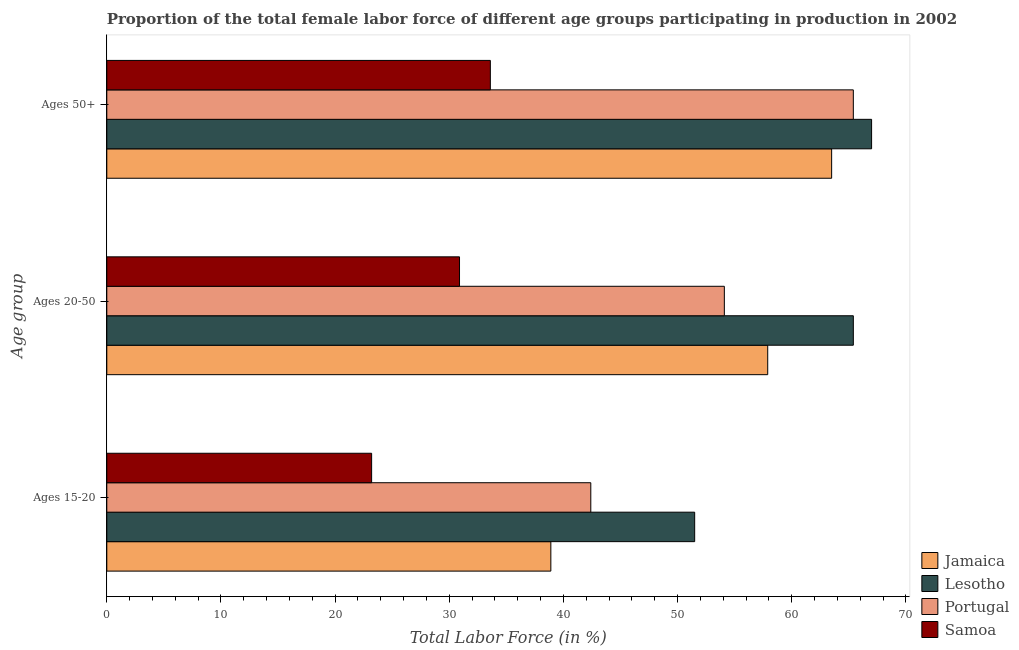Are the number of bars per tick equal to the number of legend labels?
Offer a very short reply. Yes. Are the number of bars on each tick of the Y-axis equal?
Your answer should be very brief. Yes. What is the label of the 3rd group of bars from the top?
Offer a terse response. Ages 15-20. What is the percentage of female labor force within the age group 15-20 in Samoa?
Keep it short and to the point. 23.2. Across all countries, what is the maximum percentage of female labor force within the age group 20-50?
Offer a terse response. 65.4. Across all countries, what is the minimum percentage of female labor force above age 50?
Ensure brevity in your answer.  33.6. In which country was the percentage of female labor force within the age group 20-50 maximum?
Provide a short and direct response. Lesotho. In which country was the percentage of female labor force within the age group 15-20 minimum?
Provide a succinct answer. Samoa. What is the total percentage of female labor force within the age group 20-50 in the graph?
Offer a terse response. 208.3. What is the difference between the percentage of female labor force within the age group 20-50 in Lesotho and that in Samoa?
Offer a terse response. 34.5. What is the difference between the percentage of female labor force above age 50 in Portugal and the percentage of female labor force within the age group 20-50 in Jamaica?
Offer a terse response. 7.5. What is the average percentage of female labor force within the age group 20-50 per country?
Provide a succinct answer. 52.08. What is the difference between the percentage of female labor force within the age group 15-20 and percentage of female labor force within the age group 20-50 in Samoa?
Ensure brevity in your answer.  -7.7. What is the ratio of the percentage of female labor force above age 50 in Jamaica to that in Lesotho?
Make the answer very short. 0.95. Is the percentage of female labor force above age 50 in Portugal less than that in Samoa?
Offer a terse response. No. Is the difference between the percentage of female labor force within the age group 15-20 in Portugal and Jamaica greater than the difference between the percentage of female labor force above age 50 in Portugal and Jamaica?
Provide a short and direct response. Yes. What is the difference between the highest and the second highest percentage of female labor force within the age group 20-50?
Offer a terse response. 7.5. What is the difference between the highest and the lowest percentage of female labor force within the age group 15-20?
Your answer should be very brief. 28.3. In how many countries, is the percentage of female labor force above age 50 greater than the average percentage of female labor force above age 50 taken over all countries?
Keep it short and to the point. 3. What does the 4th bar from the top in Ages 15-20 represents?
Provide a succinct answer. Jamaica. What does the 1st bar from the bottom in Ages 50+ represents?
Give a very brief answer. Jamaica. How many bars are there?
Offer a terse response. 12. Are all the bars in the graph horizontal?
Your answer should be very brief. Yes. How many countries are there in the graph?
Provide a short and direct response. 4. What is the difference between two consecutive major ticks on the X-axis?
Make the answer very short. 10. Are the values on the major ticks of X-axis written in scientific E-notation?
Offer a terse response. No. Does the graph contain any zero values?
Ensure brevity in your answer.  No. How are the legend labels stacked?
Ensure brevity in your answer.  Vertical. What is the title of the graph?
Make the answer very short. Proportion of the total female labor force of different age groups participating in production in 2002. What is the label or title of the Y-axis?
Your answer should be very brief. Age group. What is the Total Labor Force (in %) of Jamaica in Ages 15-20?
Ensure brevity in your answer.  38.9. What is the Total Labor Force (in %) of Lesotho in Ages 15-20?
Make the answer very short. 51.5. What is the Total Labor Force (in %) in Portugal in Ages 15-20?
Offer a very short reply. 42.4. What is the Total Labor Force (in %) in Samoa in Ages 15-20?
Your response must be concise. 23.2. What is the Total Labor Force (in %) in Jamaica in Ages 20-50?
Your answer should be very brief. 57.9. What is the Total Labor Force (in %) of Lesotho in Ages 20-50?
Give a very brief answer. 65.4. What is the Total Labor Force (in %) of Portugal in Ages 20-50?
Offer a terse response. 54.1. What is the Total Labor Force (in %) in Samoa in Ages 20-50?
Your answer should be compact. 30.9. What is the Total Labor Force (in %) of Jamaica in Ages 50+?
Give a very brief answer. 63.5. What is the Total Labor Force (in %) in Portugal in Ages 50+?
Provide a short and direct response. 65.4. What is the Total Labor Force (in %) of Samoa in Ages 50+?
Offer a very short reply. 33.6. Across all Age group, what is the maximum Total Labor Force (in %) of Jamaica?
Offer a terse response. 63.5. Across all Age group, what is the maximum Total Labor Force (in %) of Portugal?
Your answer should be very brief. 65.4. Across all Age group, what is the maximum Total Labor Force (in %) in Samoa?
Provide a succinct answer. 33.6. Across all Age group, what is the minimum Total Labor Force (in %) of Jamaica?
Give a very brief answer. 38.9. Across all Age group, what is the minimum Total Labor Force (in %) in Lesotho?
Provide a succinct answer. 51.5. Across all Age group, what is the minimum Total Labor Force (in %) of Portugal?
Ensure brevity in your answer.  42.4. Across all Age group, what is the minimum Total Labor Force (in %) in Samoa?
Give a very brief answer. 23.2. What is the total Total Labor Force (in %) in Jamaica in the graph?
Make the answer very short. 160.3. What is the total Total Labor Force (in %) of Lesotho in the graph?
Your response must be concise. 183.9. What is the total Total Labor Force (in %) in Portugal in the graph?
Ensure brevity in your answer.  161.9. What is the total Total Labor Force (in %) in Samoa in the graph?
Give a very brief answer. 87.7. What is the difference between the Total Labor Force (in %) of Lesotho in Ages 15-20 and that in Ages 20-50?
Provide a short and direct response. -13.9. What is the difference between the Total Labor Force (in %) of Portugal in Ages 15-20 and that in Ages 20-50?
Make the answer very short. -11.7. What is the difference between the Total Labor Force (in %) in Samoa in Ages 15-20 and that in Ages 20-50?
Provide a succinct answer. -7.7. What is the difference between the Total Labor Force (in %) of Jamaica in Ages 15-20 and that in Ages 50+?
Give a very brief answer. -24.6. What is the difference between the Total Labor Force (in %) in Lesotho in Ages 15-20 and that in Ages 50+?
Provide a succinct answer. -15.5. What is the difference between the Total Labor Force (in %) of Samoa in Ages 15-20 and that in Ages 50+?
Your response must be concise. -10.4. What is the difference between the Total Labor Force (in %) in Lesotho in Ages 20-50 and that in Ages 50+?
Offer a terse response. -1.6. What is the difference between the Total Labor Force (in %) in Portugal in Ages 20-50 and that in Ages 50+?
Provide a short and direct response. -11.3. What is the difference between the Total Labor Force (in %) of Samoa in Ages 20-50 and that in Ages 50+?
Provide a short and direct response. -2.7. What is the difference between the Total Labor Force (in %) in Jamaica in Ages 15-20 and the Total Labor Force (in %) in Lesotho in Ages 20-50?
Provide a succinct answer. -26.5. What is the difference between the Total Labor Force (in %) in Jamaica in Ages 15-20 and the Total Labor Force (in %) in Portugal in Ages 20-50?
Offer a terse response. -15.2. What is the difference between the Total Labor Force (in %) of Jamaica in Ages 15-20 and the Total Labor Force (in %) of Samoa in Ages 20-50?
Your response must be concise. 8. What is the difference between the Total Labor Force (in %) of Lesotho in Ages 15-20 and the Total Labor Force (in %) of Samoa in Ages 20-50?
Offer a very short reply. 20.6. What is the difference between the Total Labor Force (in %) of Jamaica in Ages 15-20 and the Total Labor Force (in %) of Lesotho in Ages 50+?
Make the answer very short. -28.1. What is the difference between the Total Labor Force (in %) of Jamaica in Ages 15-20 and the Total Labor Force (in %) of Portugal in Ages 50+?
Provide a succinct answer. -26.5. What is the difference between the Total Labor Force (in %) of Lesotho in Ages 15-20 and the Total Labor Force (in %) of Portugal in Ages 50+?
Your response must be concise. -13.9. What is the difference between the Total Labor Force (in %) in Lesotho in Ages 15-20 and the Total Labor Force (in %) in Samoa in Ages 50+?
Offer a very short reply. 17.9. What is the difference between the Total Labor Force (in %) of Portugal in Ages 15-20 and the Total Labor Force (in %) of Samoa in Ages 50+?
Your answer should be compact. 8.8. What is the difference between the Total Labor Force (in %) of Jamaica in Ages 20-50 and the Total Labor Force (in %) of Lesotho in Ages 50+?
Give a very brief answer. -9.1. What is the difference between the Total Labor Force (in %) of Jamaica in Ages 20-50 and the Total Labor Force (in %) of Portugal in Ages 50+?
Offer a very short reply. -7.5. What is the difference between the Total Labor Force (in %) in Jamaica in Ages 20-50 and the Total Labor Force (in %) in Samoa in Ages 50+?
Your response must be concise. 24.3. What is the difference between the Total Labor Force (in %) of Lesotho in Ages 20-50 and the Total Labor Force (in %) of Samoa in Ages 50+?
Make the answer very short. 31.8. What is the difference between the Total Labor Force (in %) in Portugal in Ages 20-50 and the Total Labor Force (in %) in Samoa in Ages 50+?
Your answer should be very brief. 20.5. What is the average Total Labor Force (in %) of Jamaica per Age group?
Give a very brief answer. 53.43. What is the average Total Labor Force (in %) of Lesotho per Age group?
Provide a short and direct response. 61.3. What is the average Total Labor Force (in %) in Portugal per Age group?
Offer a very short reply. 53.97. What is the average Total Labor Force (in %) of Samoa per Age group?
Offer a very short reply. 29.23. What is the difference between the Total Labor Force (in %) in Jamaica and Total Labor Force (in %) in Lesotho in Ages 15-20?
Give a very brief answer. -12.6. What is the difference between the Total Labor Force (in %) of Jamaica and Total Labor Force (in %) of Portugal in Ages 15-20?
Provide a short and direct response. -3.5. What is the difference between the Total Labor Force (in %) of Lesotho and Total Labor Force (in %) of Samoa in Ages 15-20?
Your response must be concise. 28.3. What is the difference between the Total Labor Force (in %) in Portugal and Total Labor Force (in %) in Samoa in Ages 15-20?
Your answer should be compact. 19.2. What is the difference between the Total Labor Force (in %) in Jamaica and Total Labor Force (in %) in Lesotho in Ages 20-50?
Your answer should be compact. -7.5. What is the difference between the Total Labor Force (in %) of Jamaica and Total Labor Force (in %) of Portugal in Ages 20-50?
Give a very brief answer. 3.8. What is the difference between the Total Labor Force (in %) of Lesotho and Total Labor Force (in %) of Portugal in Ages 20-50?
Keep it short and to the point. 11.3. What is the difference between the Total Labor Force (in %) in Lesotho and Total Labor Force (in %) in Samoa in Ages 20-50?
Provide a short and direct response. 34.5. What is the difference between the Total Labor Force (in %) in Portugal and Total Labor Force (in %) in Samoa in Ages 20-50?
Give a very brief answer. 23.2. What is the difference between the Total Labor Force (in %) of Jamaica and Total Labor Force (in %) of Samoa in Ages 50+?
Ensure brevity in your answer.  29.9. What is the difference between the Total Labor Force (in %) of Lesotho and Total Labor Force (in %) of Portugal in Ages 50+?
Ensure brevity in your answer.  1.6. What is the difference between the Total Labor Force (in %) of Lesotho and Total Labor Force (in %) of Samoa in Ages 50+?
Offer a very short reply. 33.4. What is the difference between the Total Labor Force (in %) of Portugal and Total Labor Force (in %) of Samoa in Ages 50+?
Make the answer very short. 31.8. What is the ratio of the Total Labor Force (in %) of Jamaica in Ages 15-20 to that in Ages 20-50?
Provide a succinct answer. 0.67. What is the ratio of the Total Labor Force (in %) of Lesotho in Ages 15-20 to that in Ages 20-50?
Ensure brevity in your answer.  0.79. What is the ratio of the Total Labor Force (in %) of Portugal in Ages 15-20 to that in Ages 20-50?
Your answer should be very brief. 0.78. What is the ratio of the Total Labor Force (in %) in Samoa in Ages 15-20 to that in Ages 20-50?
Give a very brief answer. 0.75. What is the ratio of the Total Labor Force (in %) in Jamaica in Ages 15-20 to that in Ages 50+?
Make the answer very short. 0.61. What is the ratio of the Total Labor Force (in %) of Lesotho in Ages 15-20 to that in Ages 50+?
Your response must be concise. 0.77. What is the ratio of the Total Labor Force (in %) of Portugal in Ages 15-20 to that in Ages 50+?
Your response must be concise. 0.65. What is the ratio of the Total Labor Force (in %) of Samoa in Ages 15-20 to that in Ages 50+?
Your answer should be compact. 0.69. What is the ratio of the Total Labor Force (in %) in Jamaica in Ages 20-50 to that in Ages 50+?
Provide a short and direct response. 0.91. What is the ratio of the Total Labor Force (in %) of Lesotho in Ages 20-50 to that in Ages 50+?
Your answer should be compact. 0.98. What is the ratio of the Total Labor Force (in %) of Portugal in Ages 20-50 to that in Ages 50+?
Provide a succinct answer. 0.83. What is the ratio of the Total Labor Force (in %) of Samoa in Ages 20-50 to that in Ages 50+?
Keep it short and to the point. 0.92. What is the difference between the highest and the second highest Total Labor Force (in %) of Lesotho?
Provide a succinct answer. 1.6. What is the difference between the highest and the second highest Total Labor Force (in %) of Portugal?
Provide a short and direct response. 11.3. What is the difference between the highest and the second highest Total Labor Force (in %) in Samoa?
Offer a very short reply. 2.7. What is the difference between the highest and the lowest Total Labor Force (in %) in Jamaica?
Give a very brief answer. 24.6. What is the difference between the highest and the lowest Total Labor Force (in %) of Samoa?
Make the answer very short. 10.4. 